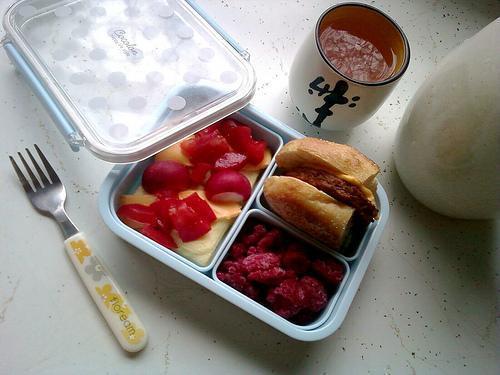How many forks are there?
Give a very brief answer. 1. 